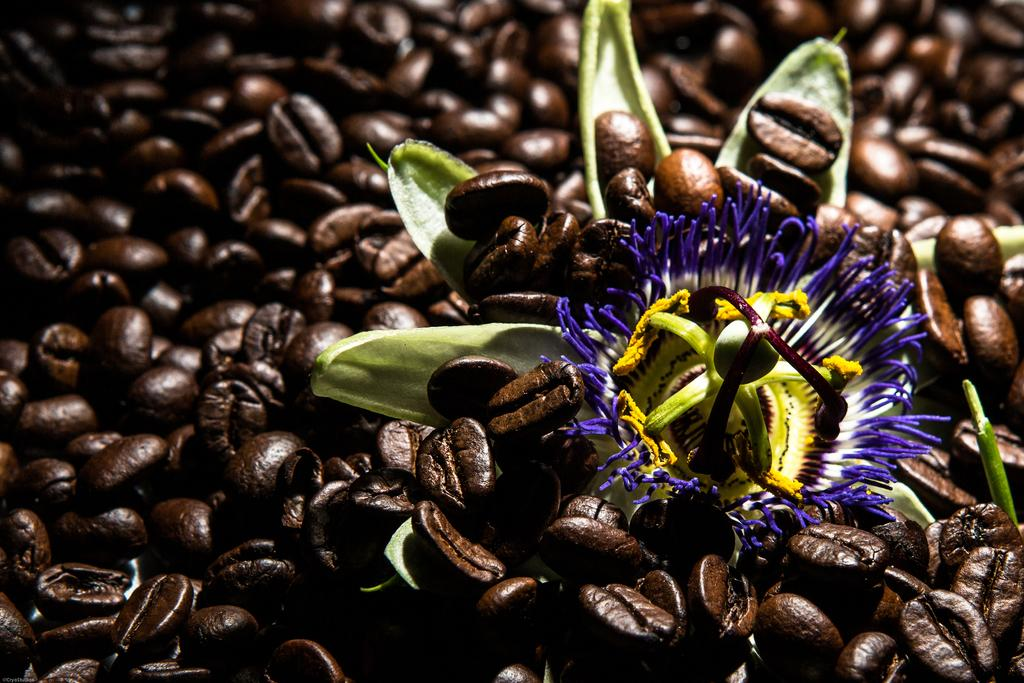What type of beans are visible in the image? There are coffee beans in the image. What other object can be seen in the image besides the coffee beans? There is a flower in the image. What type of agreement is being discussed in the image? There is no discussion or agreement present in the image; it only features coffee beans and a flower. 